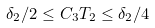<formula> <loc_0><loc_0><loc_500><loc_500>\delta _ { 2 } / 2 \leq C _ { 3 } T _ { 2 } \leq \delta _ { 2 } / 4</formula> 